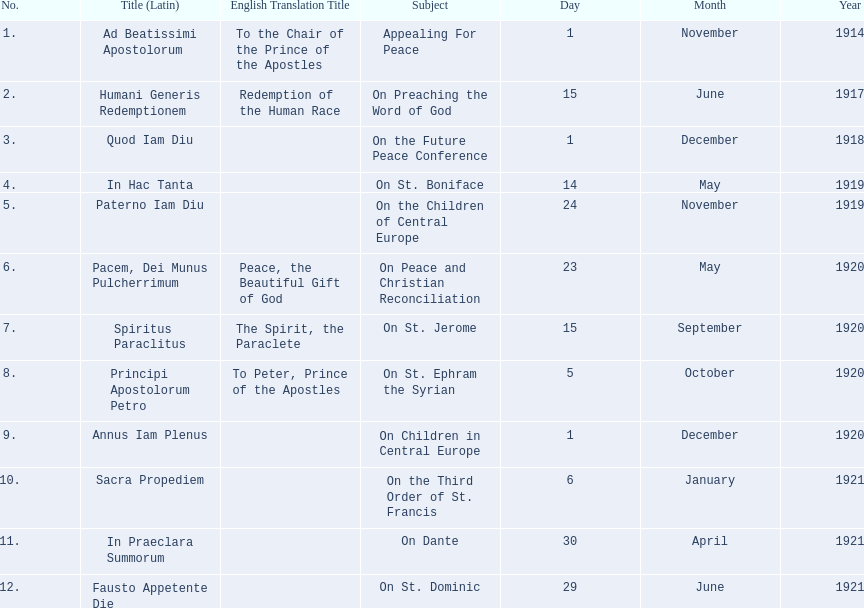What are all the subjects? Appealing For Peace, On Preaching the Word of God, On the Future Peace Conference, On St. Boniface, On the Children of Central Europe, On Peace and Christian Reconciliation, On St. Jerome, On St. Ephram the Syrian, On Children in Central Europe, On the Third Order of St. Francis, On Dante, On St. Dominic. What are their dates? 1 November 1914, 15 June 1917, 1 December 1918, 14 May 1919, 24 November 1919, 23 May 1920, 15 September 1920, 5 October 1920, 1 December 1920, 6 January 1921, 30 April 1921, 29 June 1921. Which subject's date belongs to 23 may 1920? On Peace and Christian Reconciliation. Can you give me this table as a dict? {'header': ['No.', 'Title (Latin)', 'English Translation Title', 'Subject', 'Day', 'Month', 'Year'], 'rows': [['1.', 'Ad Beatissimi Apostolorum', 'To the Chair of the Prince of the Apostles', 'Appealing For Peace', '1', 'November', '1914'], ['2.', 'Humani Generis Redemptionem', 'Redemption of the Human Race', 'On Preaching the Word of God', '15', 'June', '1917'], ['3.', 'Quod Iam Diu', '', 'On the Future Peace Conference', '1', 'December', '1918'], ['4.', 'In Hac Tanta', '', 'On St. Boniface', '14', 'May', '1919'], ['5.', 'Paterno Iam Diu', '', 'On the Children of Central Europe', '24', 'November', '1919'], ['6.', 'Pacem, Dei Munus Pulcherrimum', 'Peace, the Beautiful Gift of God', 'On Peace and Christian Reconciliation', '23', 'May', '1920'], ['7.', 'Spiritus Paraclitus', 'The Spirit, the Paraclete', 'On St. Jerome', '15', 'September', '1920'], ['8.', 'Principi Apostolorum Petro', 'To Peter, Prince of the Apostles', 'On St. Ephram the Syrian', '5', 'October', '1920'], ['9.', 'Annus Iam Plenus', '', 'On Children in Central Europe', '1', 'December', '1920'], ['10.', 'Sacra Propediem', '', 'On the Third Order of St. Francis', '6', 'January', '1921'], ['11.', 'In Praeclara Summorum', '', 'On Dante', '30', 'April', '1921'], ['12.', 'Fausto Appetente Die', '', 'On St. Dominic', '29', 'June', '1921']]} 